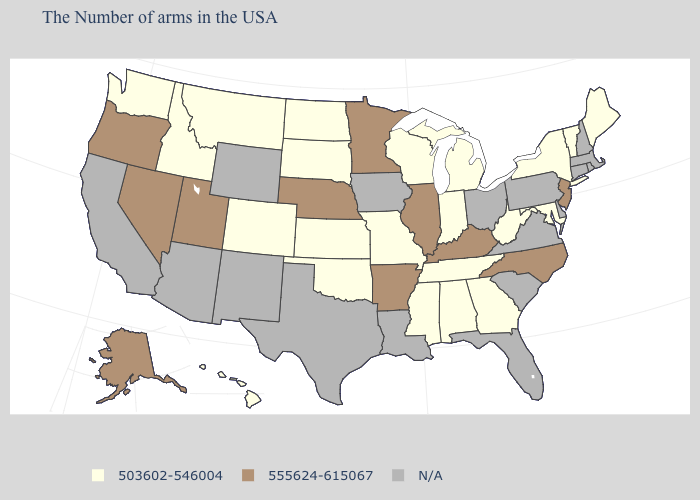Name the states that have a value in the range 503602-546004?
Give a very brief answer. Maine, Vermont, New York, Maryland, West Virginia, Georgia, Michigan, Indiana, Alabama, Tennessee, Wisconsin, Mississippi, Missouri, Kansas, Oklahoma, South Dakota, North Dakota, Colorado, Montana, Idaho, Washington, Hawaii. Name the states that have a value in the range N/A?
Quick response, please. Massachusetts, Rhode Island, New Hampshire, Connecticut, Delaware, Pennsylvania, Virginia, South Carolina, Ohio, Florida, Louisiana, Iowa, Texas, Wyoming, New Mexico, Arizona, California. What is the value of Alaska?
Give a very brief answer. 555624-615067. Among the states that border Wisconsin , does Michigan have the lowest value?
Give a very brief answer. Yes. What is the lowest value in the USA?
Write a very short answer. 503602-546004. Which states have the lowest value in the USA?
Quick response, please. Maine, Vermont, New York, Maryland, West Virginia, Georgia, Michigan, Indiana, Alabama, Tennessee, Wisconsin, Mississippi, Missouri, Kansas, Oklahoma, South Dakota, North Dakota, Colorado, Montana, Idaho, Washington, Hawaii. Which states have the lowest value in the MidWest?
Be succinct. Michigan, Indiana, Wisconsin, Missouri, Kansas, South Dakota, North Dakota. Does Kentucky have the highest value in the USA?
Write a very short answer. Yes. What is the value of Michigan?
Write a very short answer. 503602-546004. Name the states that have a value in the range N/A?
Give a very brief answer. Massachusetts, Rhode Island, New Hampshire, Connecticut, Delaware, Pennsylvania, Virginia, South Carolina, Ohio, Florida, Louisiana, Iowa, Texas, Wyoming, New Mexico, Arizona, California. Name the states that have a value in the range 555624-615067?
Keep it brief. New Jersey, North Carolina, Kentucky, Illinois, Arkansas, Minnesota, Nebraska, Utah, Nevada, Oregon, Alaska. Name the states that have a value in the range 503602-546004?
Keep it brief. Maine, Vermont, New York, Maryland, West Virginia, Georgia, Michigan, Indiana, Alabama, Tennessee, Wisconsin, Mississippi, Missouri, Kansas, Oklahoma, South Dakota, North Dakota, Colorado, Montana, Idaho, Washington, Hawaii. Name the states that have a value in the range 503602-546004?
Give a very brief answer. Maine, Vermont, New York, Maryland, West Virginia, Georgia, Michigan, Indiana, Alabama, Tennessee, Wisconsin, Mississippi, Missouri, Kansas, Oklahoma, South Dakota, North Dakota, Colorado, Montana, Idaho, Washington, Hawaii. What is the value of Maine?
Be succinct. 503602-546004. 